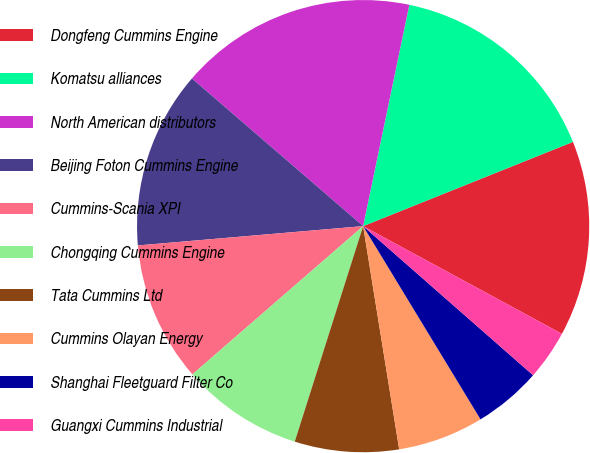<chart> <loc_0><loc_0><loc_500><loc_500><pie_chart><fcel>Dongfeng Cummins Engine<fcel>Komatsu alliances<fcel>North American distributors<fcel>Beijing Foton Cummins Engine<fcel>Cummins-Scania XPI<fcel>Chongqing Cummins Engine<fcel>Tata Cummins Ltd<fcel>Cummins Olayan Energy<fcel>Shanghai Fleetguard Filter Co<fcel>Guangxi Cummins Industrial<nl><fcel>13.98%<fcel>15.65%<fcel>16.95%<fcel>12.69%<fcel>10.02%<fcel>8.73%<fcel>7.44%<fcel>6.14%<fcel>4.85%<fcel>3.56%<nl></chart> 